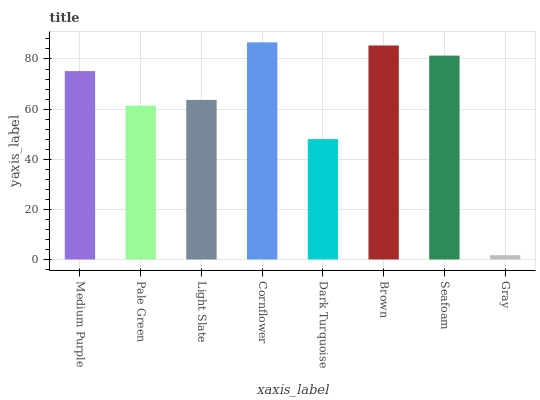Is Gray the minimum?
Answer yes or no. Yes. Is Cornflower the maximum?
Answer yes or no. Yes. Is Pale Green the minimum?
Answer yes or no. No. Is Pale Green the maximum?
Answer yes or no. No. Is Medium Purple greater than Pale Green?
Answer yes or no. Yes. Is Pale Green less than Medium Purple?
Answer yes or no. Yes. Is Pale Green greater than Medium Purple?
Answer yes or no. No. Is Medium Purple less than Pale Green?
Answer yes or no. No. Is Medium Purple the high median?
Answer yes or no. Yes. Is Light Slate the low median?
Answer yes or no. Yes. Is Cornflower the high median?
Answer yes or no. No. Is Dark Turquoise the low median?
Answer yes or no. No. 